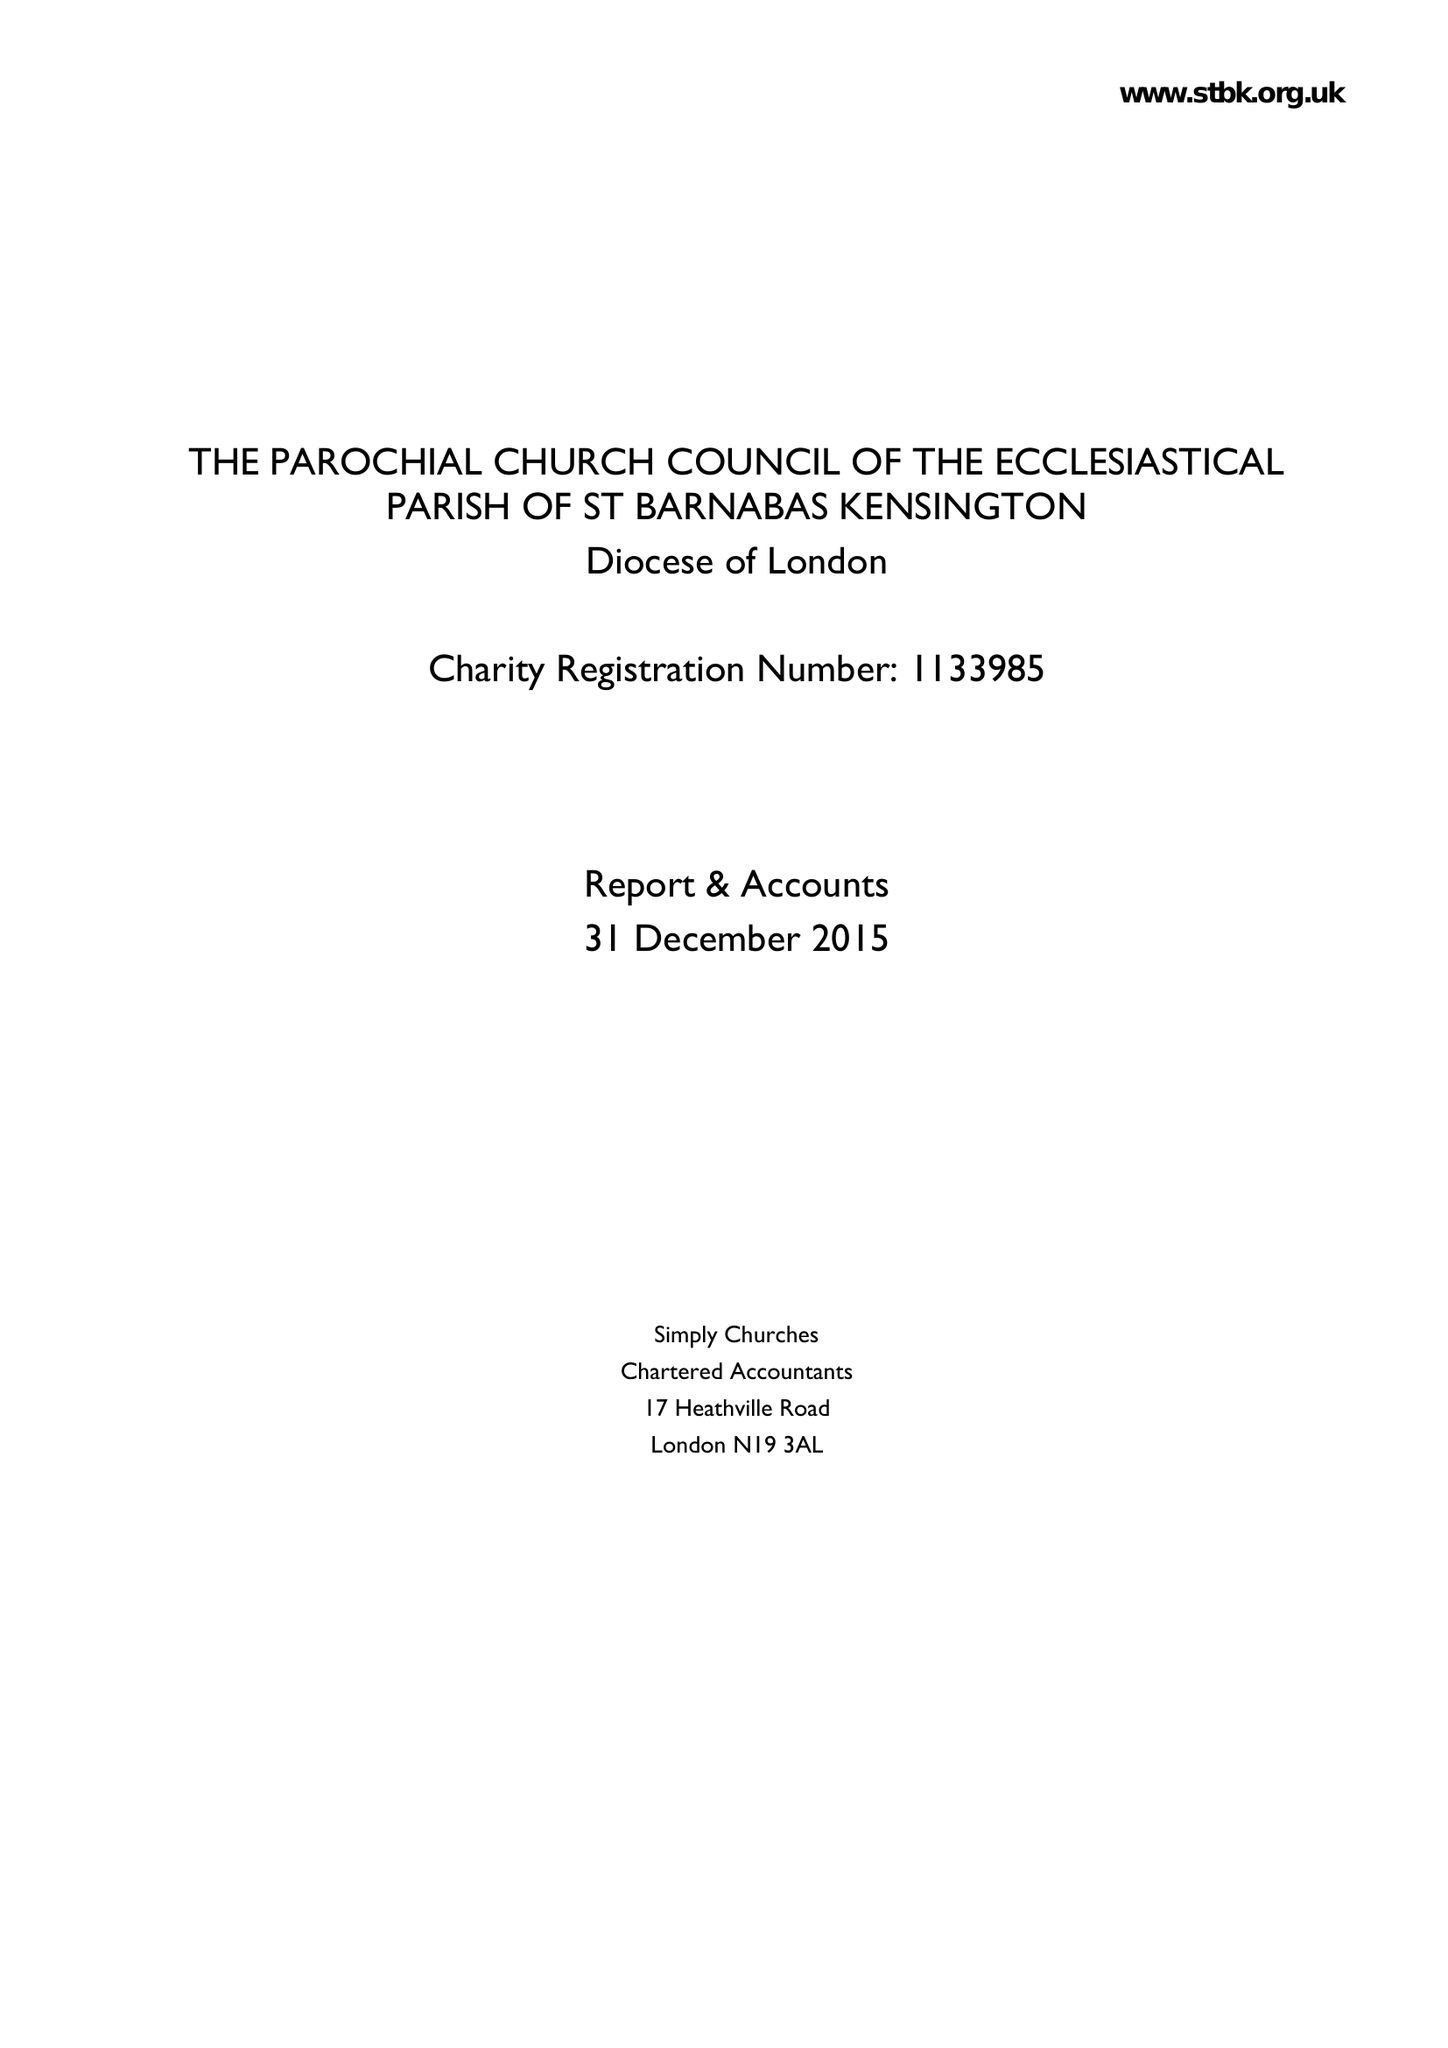What is the value for the charity_number?
Answer the question using a single word or phrase. 1133985 